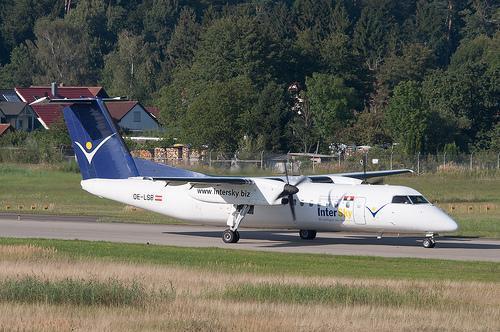How many planes are there?
Give a very brief answer. 1. 